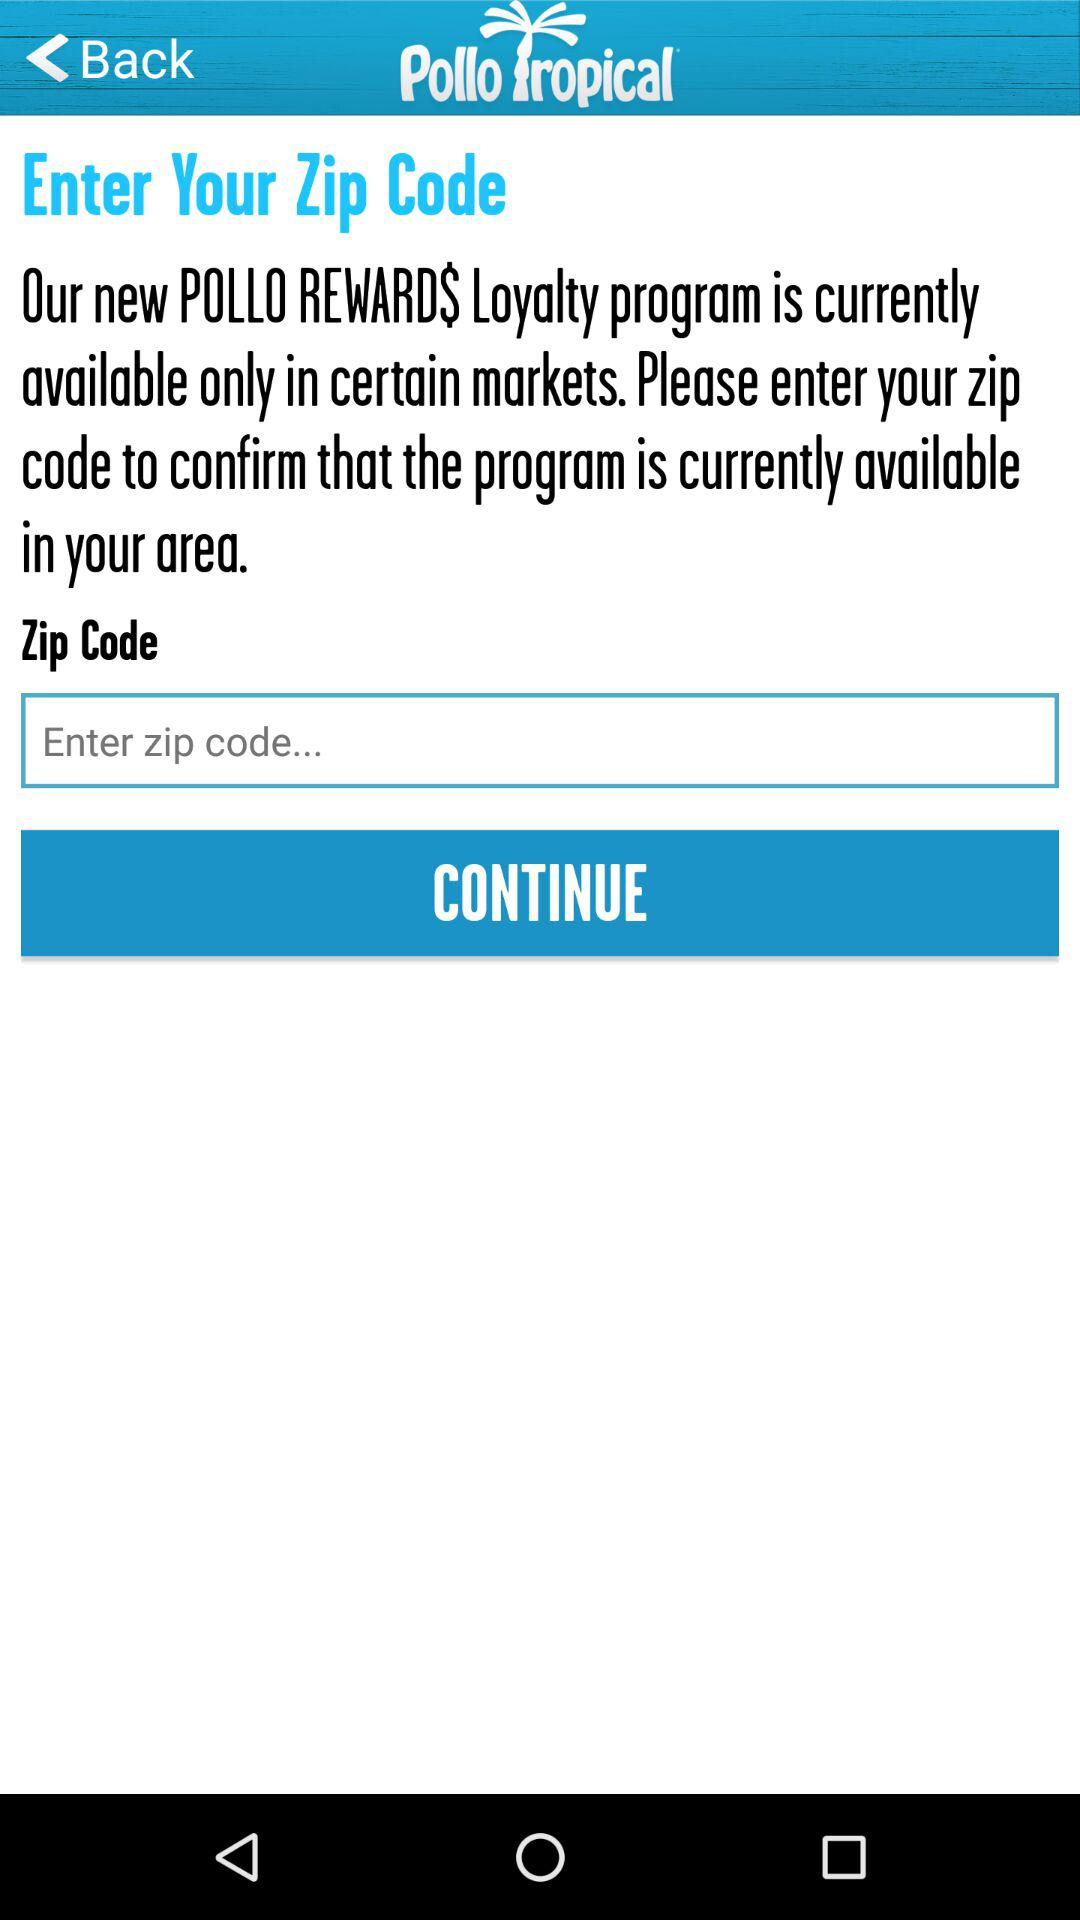What is the name of the application? The name of the application is "Pollo Tropical". 